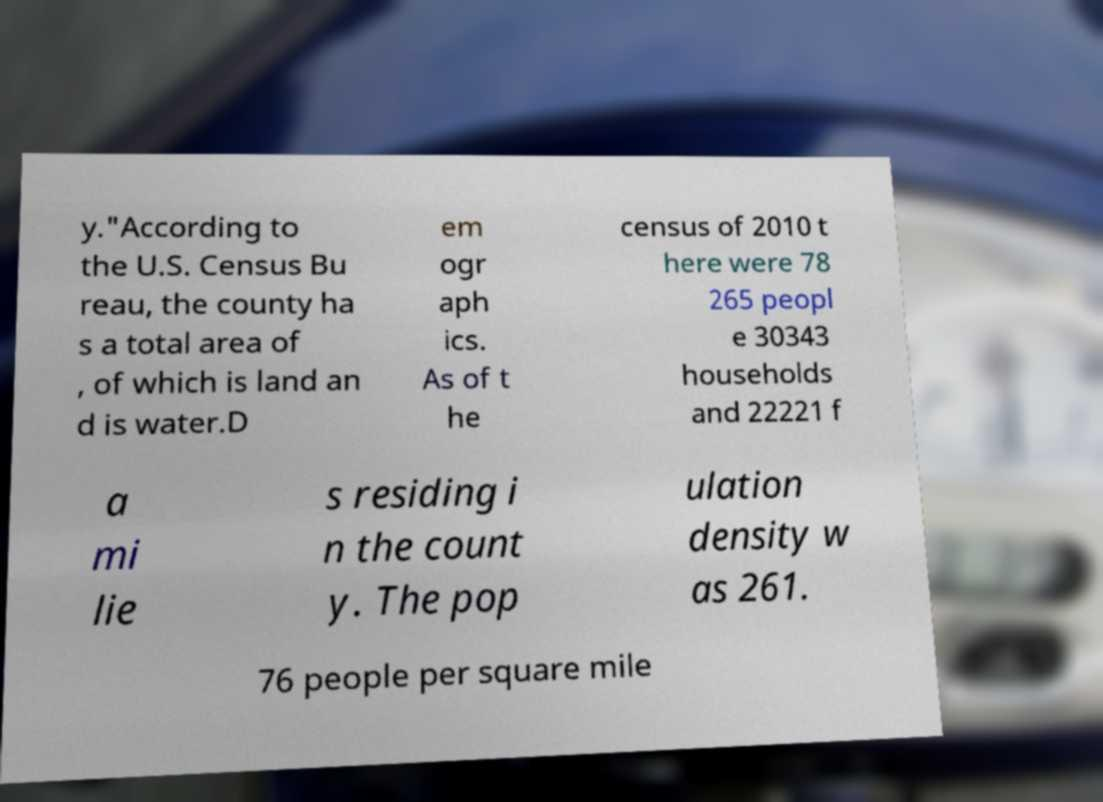For documentation purposes, I need the text within this image transcribed. Could you provide that? y."According to the U.S. Census Bu reau, the county ha s a total area of , of which is land an d is water.D em ogr aph ics. As of t he census of 2010 t here were 78 265 peopl e 30343 households and 22221 f a mi lie s residing i n the count y. The pop ulation density w as 261. 76 people per square mile 